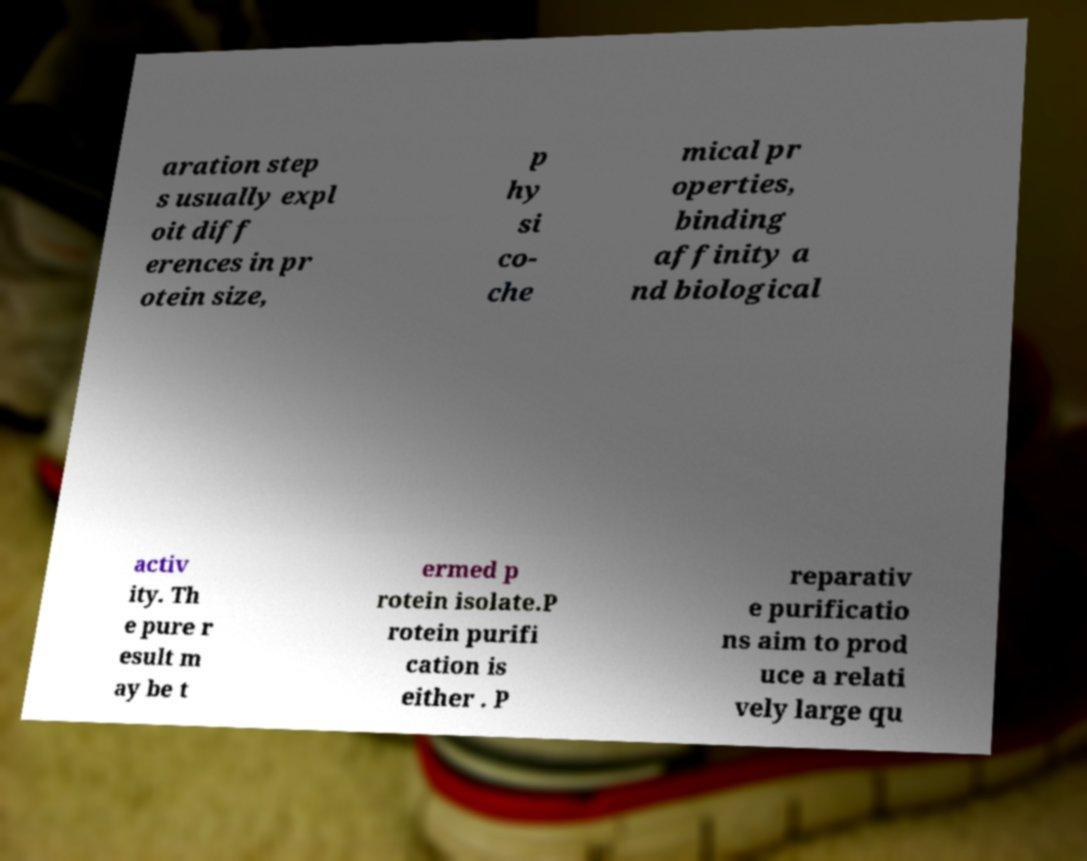Could you assist in decoding the text presented in this image and type it out clearly? aration step s usually expl oit diff erences in pr otein size, p hy si co- che mical pr operties, binding affinity a nd biological activ ity. Th e pure r esult m ay be t ermed p rotein isolate.P rotein purifi cation is either . P reparativ e purificatio ns aim to prod uce a relati vely large qu 